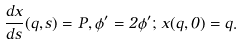<formula> <loc_0><loc_0><loc_500><loc_500>\frac { d x } { d s } ( q , s ) = P , \phi ^ { \prime } = 2 \phi ^ { \prime } ; \, x ( q , 0 ) = q .</formula> 